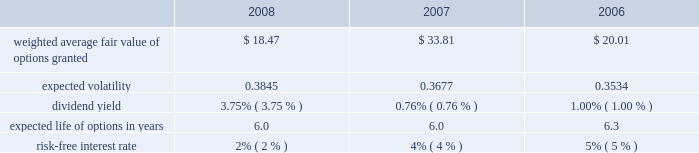
The black-scholes option valuation model was developed for use in estimating the fair value of traded options which have no vesting restrictions and are fully transferable .
In addition , option valuation models require the input of highly subjective assumptions , including the expected stock price volatility .
Because the company 2019s employee stock options have characteristics significantly different from those of traded options , and because changes in the subjective input assumptions can materially affect the fair value estimate , in management 2019s opinion , the existing models do not necessarily provide a reliable single measure of the fair value of its employee stock options .
The fair value of the rsus was determined based on the market value at the date of grant .
The total fair value of awards vested during 2008 , 2007 , and 2006 was $ 35384 , $ 17840 , and $ 9413 , respectively .
The total stock based compensation expense calculated using the black-scholes option valuation model in 2008 , 2007 , and 2006 was $ 38872 , $ 22164 , and $ 11913 , respectively.the aggregate intrinsic values of options outstanding and exercisable at december 27 , 2008 were $ 8.2 million and $ 8.2 million , respectively .
The aggregate intrinsic value of options exercised during the year ended december 27 , 2008 was $ 0.6 million .
Aggregate intrinsic value represents the positive difference between the company 2019s closing stock price on the last trading day of the fiscal period , which was $ 19.39 on december 27 , 2008 , and the exercise price multiplied by the number of options exercised .
As of december 27 , 2008 , there was $ 141.7 million of total unrecognized compensation cost related to unvested share-based compensation awards granted to employees under the stock compensation plans .
That cost is expected to be recognized over a period of five years .
Employee stock purchase plan the shareholders also adopted an employee stock purchase plan ( espp ) .
Up to 2000000 shares of common stock have been reserved for the espp .
Shares will be offered to employees at a price equal to the lesser of 85% ( 85 % ) of the fair market value of the stock on the date of purchase or 85% ( 85 % ) of the fair market value on the enrollment date .
The espp is intended to qualify as an 201cemployee stock purchase plan 201d under section 423 of the internal revenue code .
During 2008 , 2007 , and 2006 , 362902 , 120230 , and 124693 shares , respectively were purchased under the plan for a total purchase price of $ 8782 , $ 5730 , and $ 3569 , respectively .
At december 27 , 2008 , approximately 663679 shares were available for future issuance .
10 .
Earnings per share the following table sets forth the computation of basic and diluted net income per share: .
What was the estimated percentual increase in the expected volatility observed during 2007 and 2008? 
Rationale: it is the expected volatility in 2008 divided by the expected volatility in 2007 , then transformed into a percentage .
Computations: ((0.3845 / 0.3677) - 1)
Answer: 0.04569. 